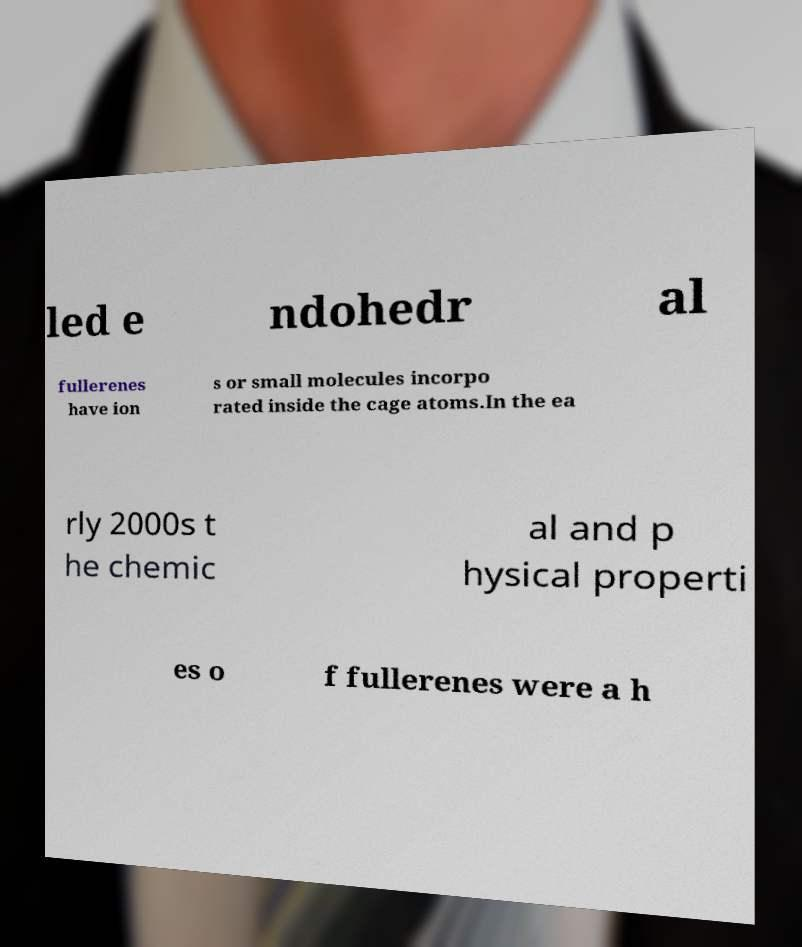Could you assist in decoding the text presented in this image and type it out clearly? led e ndohedr al fullerenes have ion s or small molecules incorpo rated inside the cage atoms.In the ea rly 2000s t he chemic al and p hysical properti es o f fullerenes were a h 